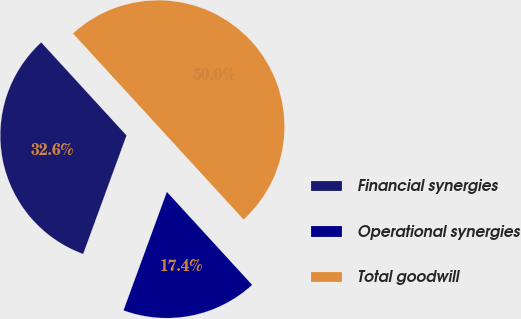Convert chart. <chart><loc_0><loc_0><loc_500><loc_500><pie_chart><fcel>Financial synergies<fcel>Operational synergies<fcel>Total goodwill<nl><fcel>32.61%<fcel>17.39%<fcel>50.0%<nl></chart> 